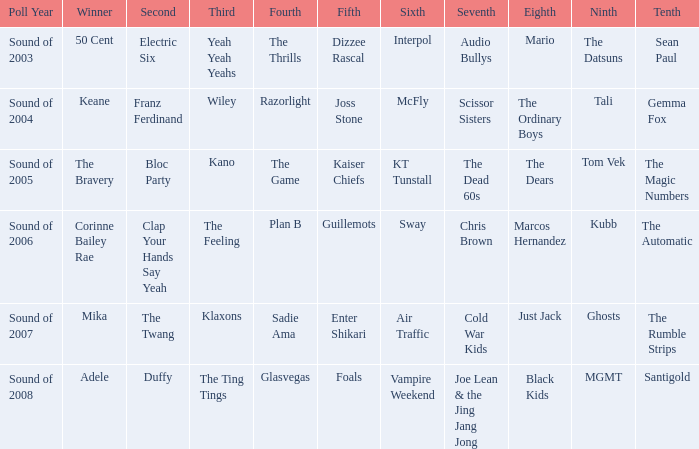When interpol occupies the 6th place, who comes in at 7th? 1.0. 